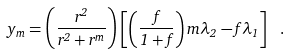<formula> <loc_0><loc_0><loc_500><loc_500>y _ { m } = \left ( \frac { r ^ { 2 } } { r ^ { 2 } + r ^ { m } } \right ) \left [ \left ( \frac { f } { 1 + f } \right ) m \lambda _ { 2 } - f \lambda _ { 1 } \right ] \ .</formula> 